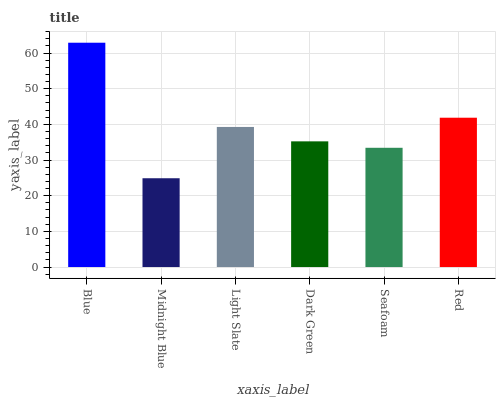Is Midnight Blue the minimum?
Answer yes or no. Yes. Is Blue the maximum?
Answer yes or no. Yes. Is Light Slate the minimum?
Answer yes or no. No. Is Light Slate the maximum?
Answer yes or no. No. Is Light Slate greater than Midnight Blue?
Answer yes or no. Yes. Is Midnight Blue less than Light Slate?
Answer yes or no. Yes. Is Midnight Blue greater than Light Slate?
Answer yes or no. No. Is Light Slate less than Midnight Blue?
Answer yes or no. No. Is Light Slate the high median?
Answer yes or no. Yes. Is Dark Green the low median?
Answer yes or no. Yes. Is Blue the high median?
Answer yes or no. No. Is Midnight Blue the low median?
Answer yes or no. No. 